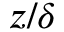<formula> <loc_0><loc_0><loc_500><loc_500>z / \delta</formula> 